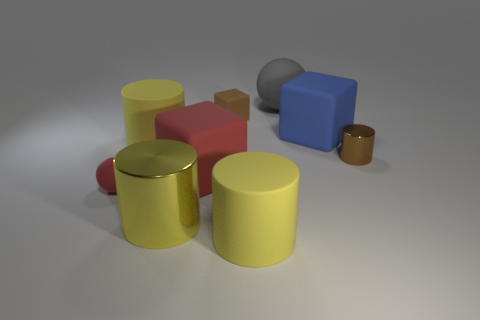Subtract all big metal cylinders. How many cylinders are left? 3 Subtract all blue blocks. How many blocks are left? 2 Subtract all blue blocks. How many yellow cylinders are left? 3 Subtract all balls. How many objects are left? 7 Subtract all green balls. Subtract all gray blocks. How many balls are left? 2 Subtract all tiny gray matte cylinders. Subtract all brown metal objects. How many objects are left? 8 Add 4 tiny blocks. How many tiny blocks are left? 5 Add 2 large green metal cubes. How many large green metal cubes exist? 2 Subtract 1 red spheres. How many objects are left? 8 